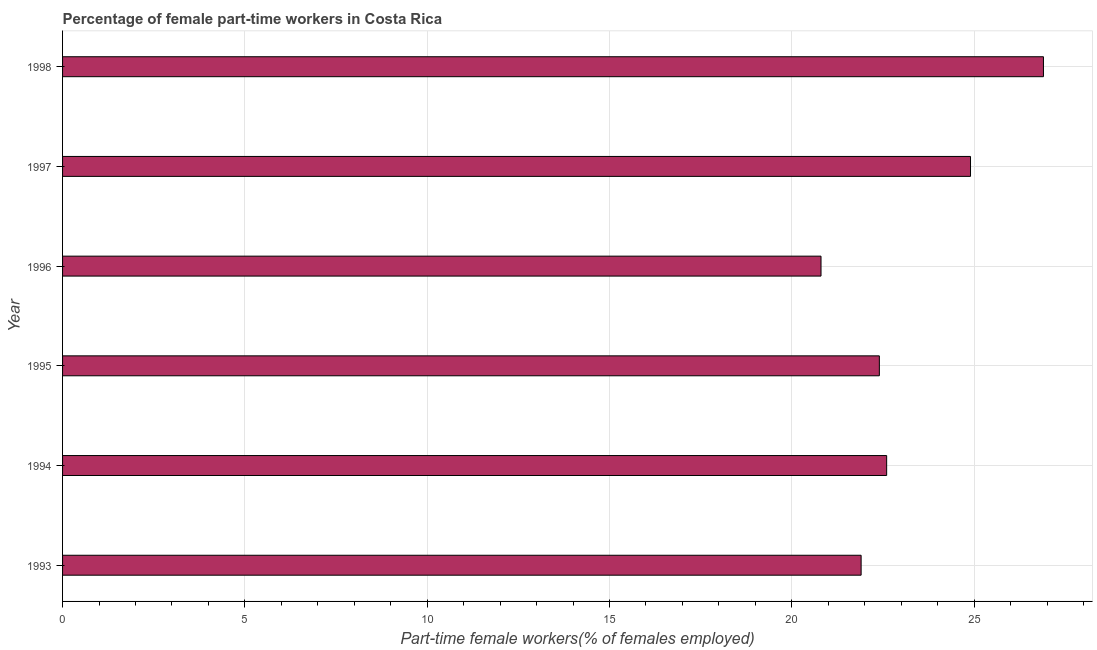Does the graph contain any zero values?
Your answer should be compact. No. What is the title of the graph?
Your answer should be very brief. Percentage of female part-time workers in Costa Rica. What is the label or title of the X-axis?
Give a very brief answer. Part-time female workers(% of females employed). What is the label or title of the Y-axis?
Your answer should be very brief. Year. What is the percentage of part-time female workers in 1996?
Your answer should be very brief. 20.8. Across all years, what is the maximum percentage of part-time female workers?
Provide a succinct answer. 26.9. Across all years, what is the minimum percentage of part-time female workers?
Your answer should be compact. 20.8. In which year was the percentage of part-time female workers minimum?
Your response must be concise. 1996. What is the sum of the percentage of part-time female workers?
Your response must be concise. 139.5. What is the difference between the percentage of part-time female workers in 1993 and 1994?
Your answer should be very brief. -0.7. What is the average percentage of part-time female workers per year?
Offer a very short reply. 23.25. Do a majority of the years between 1995 and 1997 (inclusive) have percentage of part-time female workers greater than 19 %?
Your answer should be very brief. Yes. What is the ratio of the percentage of part-time female workers in 1993 to that in 1998?
Offer a terse response. 0.81. What is the difference between the highest and the lowest percentage of part-time female workers?
Ensure brevity in your answer.  6.1. In how many years, is the percentage of part-time female workers greater than the average percentage of part-time female workers taken over all years?
Give a very brief answer. 2. What is the Part-time female workers(% of females employed) in 1993?
Your answer should be very brief. 21.9. What is the Part-time female workers(% of females employed) of 1994?
Make the answer very short. 22.6. What is the Part-time female workers(% of females employed) in 1995?
Offer a very short reply. 22.4. What is the Part-time female workers(% of females employed) of 1996?
Make the answer very short. 20.8. What is the Part-time female workers(% of females employed) in 1997?
Offer a very short reply. 24.9. What is the Part-time female workers(% of females employed) of 1998?
Your answer should be compact. 26.9. What is the difference between the Part-time female workers(% of females employed) in 1993 and 1995?
Offer a very short reply. -0.5. What is the difference between the Part-time female workers(% of females employed) in 1993 and 1998?
Your answer should be very brief. -5. What is the difference between the Part-time female workers(% of females employed) in 1994 and 1996?
Offer a very short reply. 1.8. What is the difference between the Part-time female workers(% of females employed) in 1994 and 1998?
Provide a succinct answer. -4.3. What is the difference between the Part-time female workers(% of females employed) in 1995 and 1996?
Provide a succinct answer. 1.6. What is the difference between the Part-time female workers(% of females employed) in 1995 and 1997?
Make the answer very short. -2.5. What is the difference between the Part-time female workers(% of females employed) in 1995 and 1998?
Your response must be concise. -4.5. What is the difference between the Part-time female workers(% of females employed) in 1996 and 1997?
Make the answer very short. -4.1. What is the difference between the Part-time female workers(% of females employed) in 1997 and 1998?
Your answer should be very brief. -2. What is the ratio of the Part-time female workers(% of females employed) in 1993 to that in 1994?
Your answer should be compact. 0.97. What is the ratio of the Part-time female workers(% of females employed) in 1993 to that in 1996?
Provide a succinct answer. 1.05. What is the ratio of the Part-time female workers(% of females employed) in 1993 to that in 1997?
Offer a terse response. 0.88. What is the ratio of the Part-time female workers(% of females employed) in 1993 to that in 1998?
Your response must be concise. 0.81. What is the ratio of the Part-time female workers(% of females employed) in 1994 to that in 1995?
Make the answer very short. 1.01. What is the ratio of the Part-time female workers(% of females employed) in 1994 to that in 1996?
Your response must be concise. 1.09. What is the ratio of the Part-time female workers(% of females employed) in 1994 to that in 1997?
Provide a succinct answer. 0.91. What is the ratio of the Part-time female workers(% of females employed) in 1994 to that in 1998?
Your answer should be very brief. 0.84. What is the ratio of the Part-time female workers(% of females employed) in 1995 to that in 1996?
Provide a short and direct response. 1.08. What is the ratio of the Part-time female workers(% of females employed) in 1995 to that in 1997?
Make the answer very short. 0.9. What is the ratio of the Part-time female workers(% of females employed) in 1995 to that in 1998?
Make the answer very short. 0.83. What is the ratio of the Part-time female workers(% of females employed) in 1996 to that in 1997?
Your answer should be very brief. 0.83. What is the ratio of the Part-time female workers(% of females employed) in 1996 to that in 1998?
Your answer should be compact. 0.77. What is the ratio of the Part-time female workers(% of females employed) in 1997 to that in 1998?
Give a very brief answer. 0.93. 